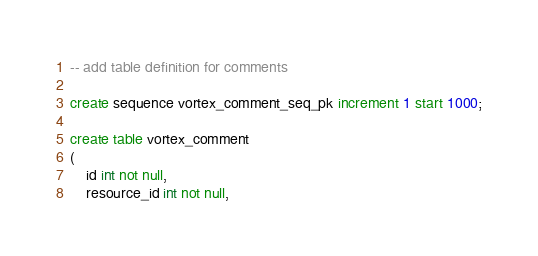Convert code to text. <code><loc_0><loc_0><loc_500><loc_500><_SQL_>
-- add table definition for comments

create sequence vortex_comment_seq_pk increment 1 start 1000;

create table vortex_comment
(
    id int not null,
    resource_id int not null,</code> 